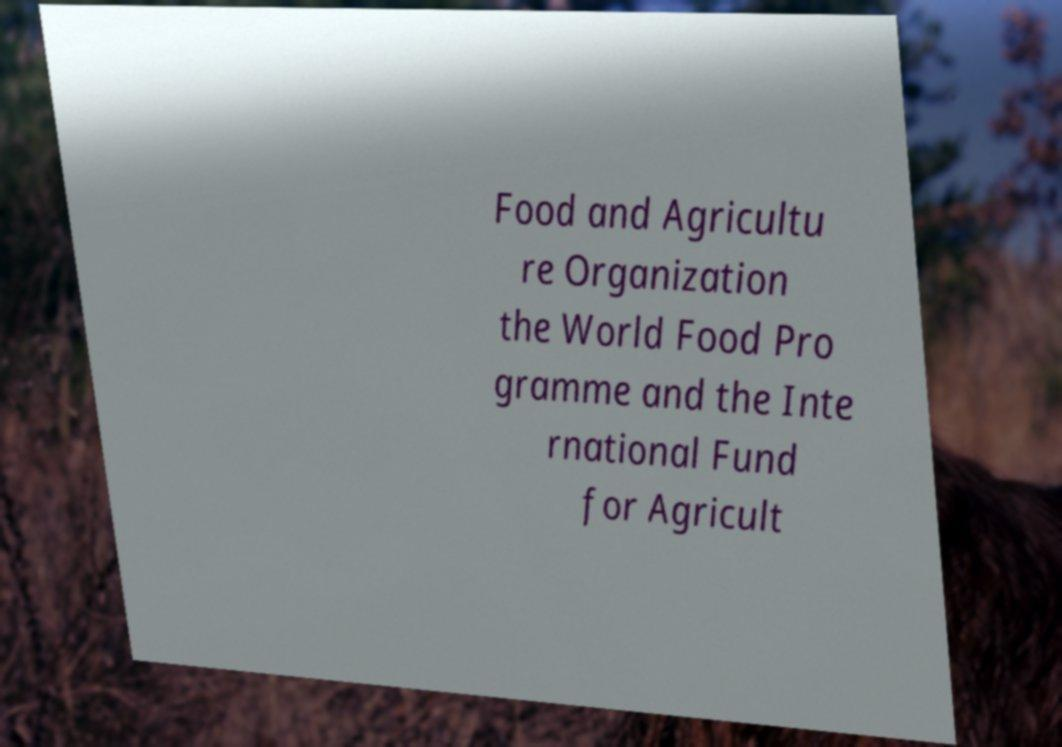There's text embedded in this image that I need extracted. Can you transcribe it verbatim? Food and Agricultu re Organization the World Food Pro gramme and the Inte rnational Fund for Agricult 